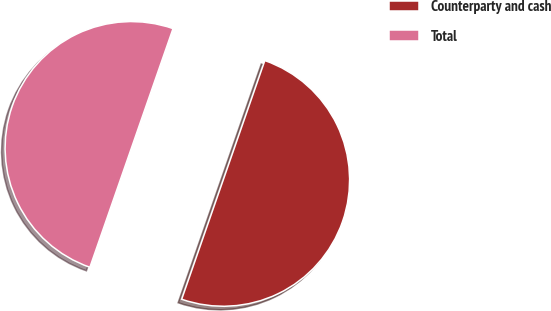Convert chart to OTSL. <chart><loc_0><loc_0><loc_500><loc_500><pie_chart><fcel>Counterparty and cash<fcel>Total<nl><fcel>50.0%<fcel>50.0%<nl></chart> 